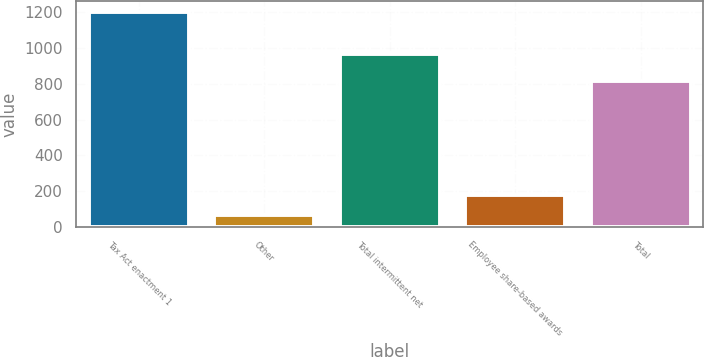Convert chart. <chart><loc_0><loc_0><loc_500><loc_500><bar_chart><fcel>Tax Act enactment 1<fcel>Other<fcel>Total intermittent net<fcel>Employee share-based awards<fcel>Total<nl><fcel>1201<fcel>65<fcel>968<fcel>178.6<fcel>813<nl></chart> 